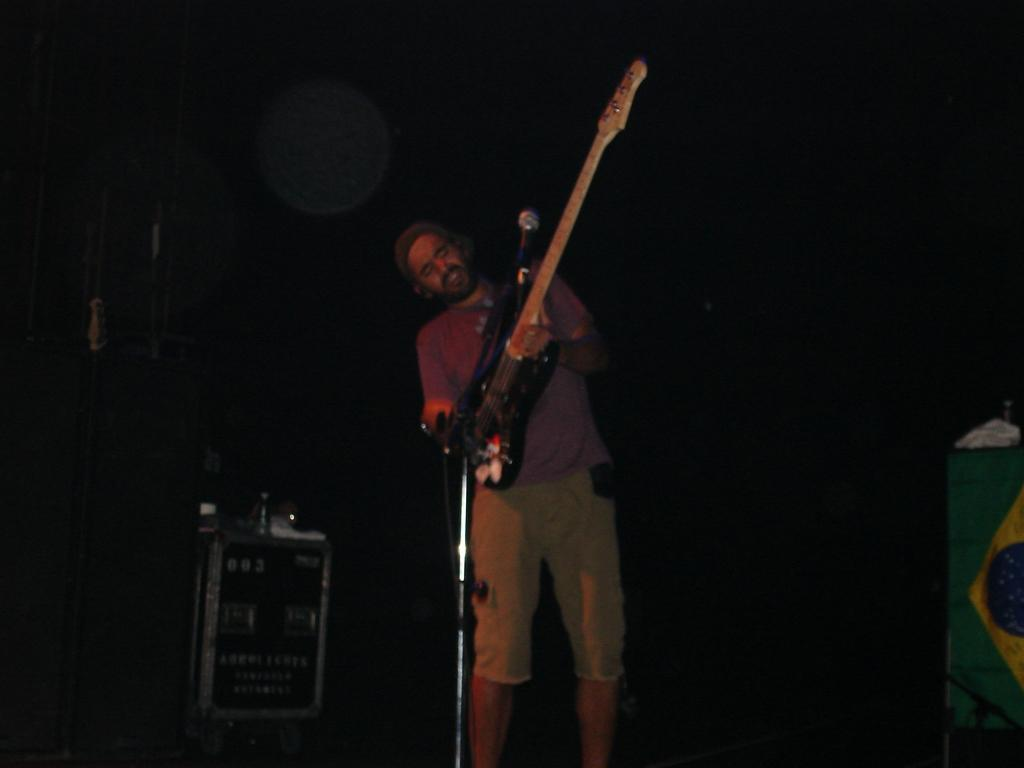What is the main subject of the image? There is a person in the image. Where is the person located in the image? The person is standing in the center. What is the person doing in the image? The person is playing a guitar and singing on a microphone. What type of cart is being used to transport the wood in the image? There is no cart or wood present in the image; it features a person playing a guitar and singing on a microphone. 